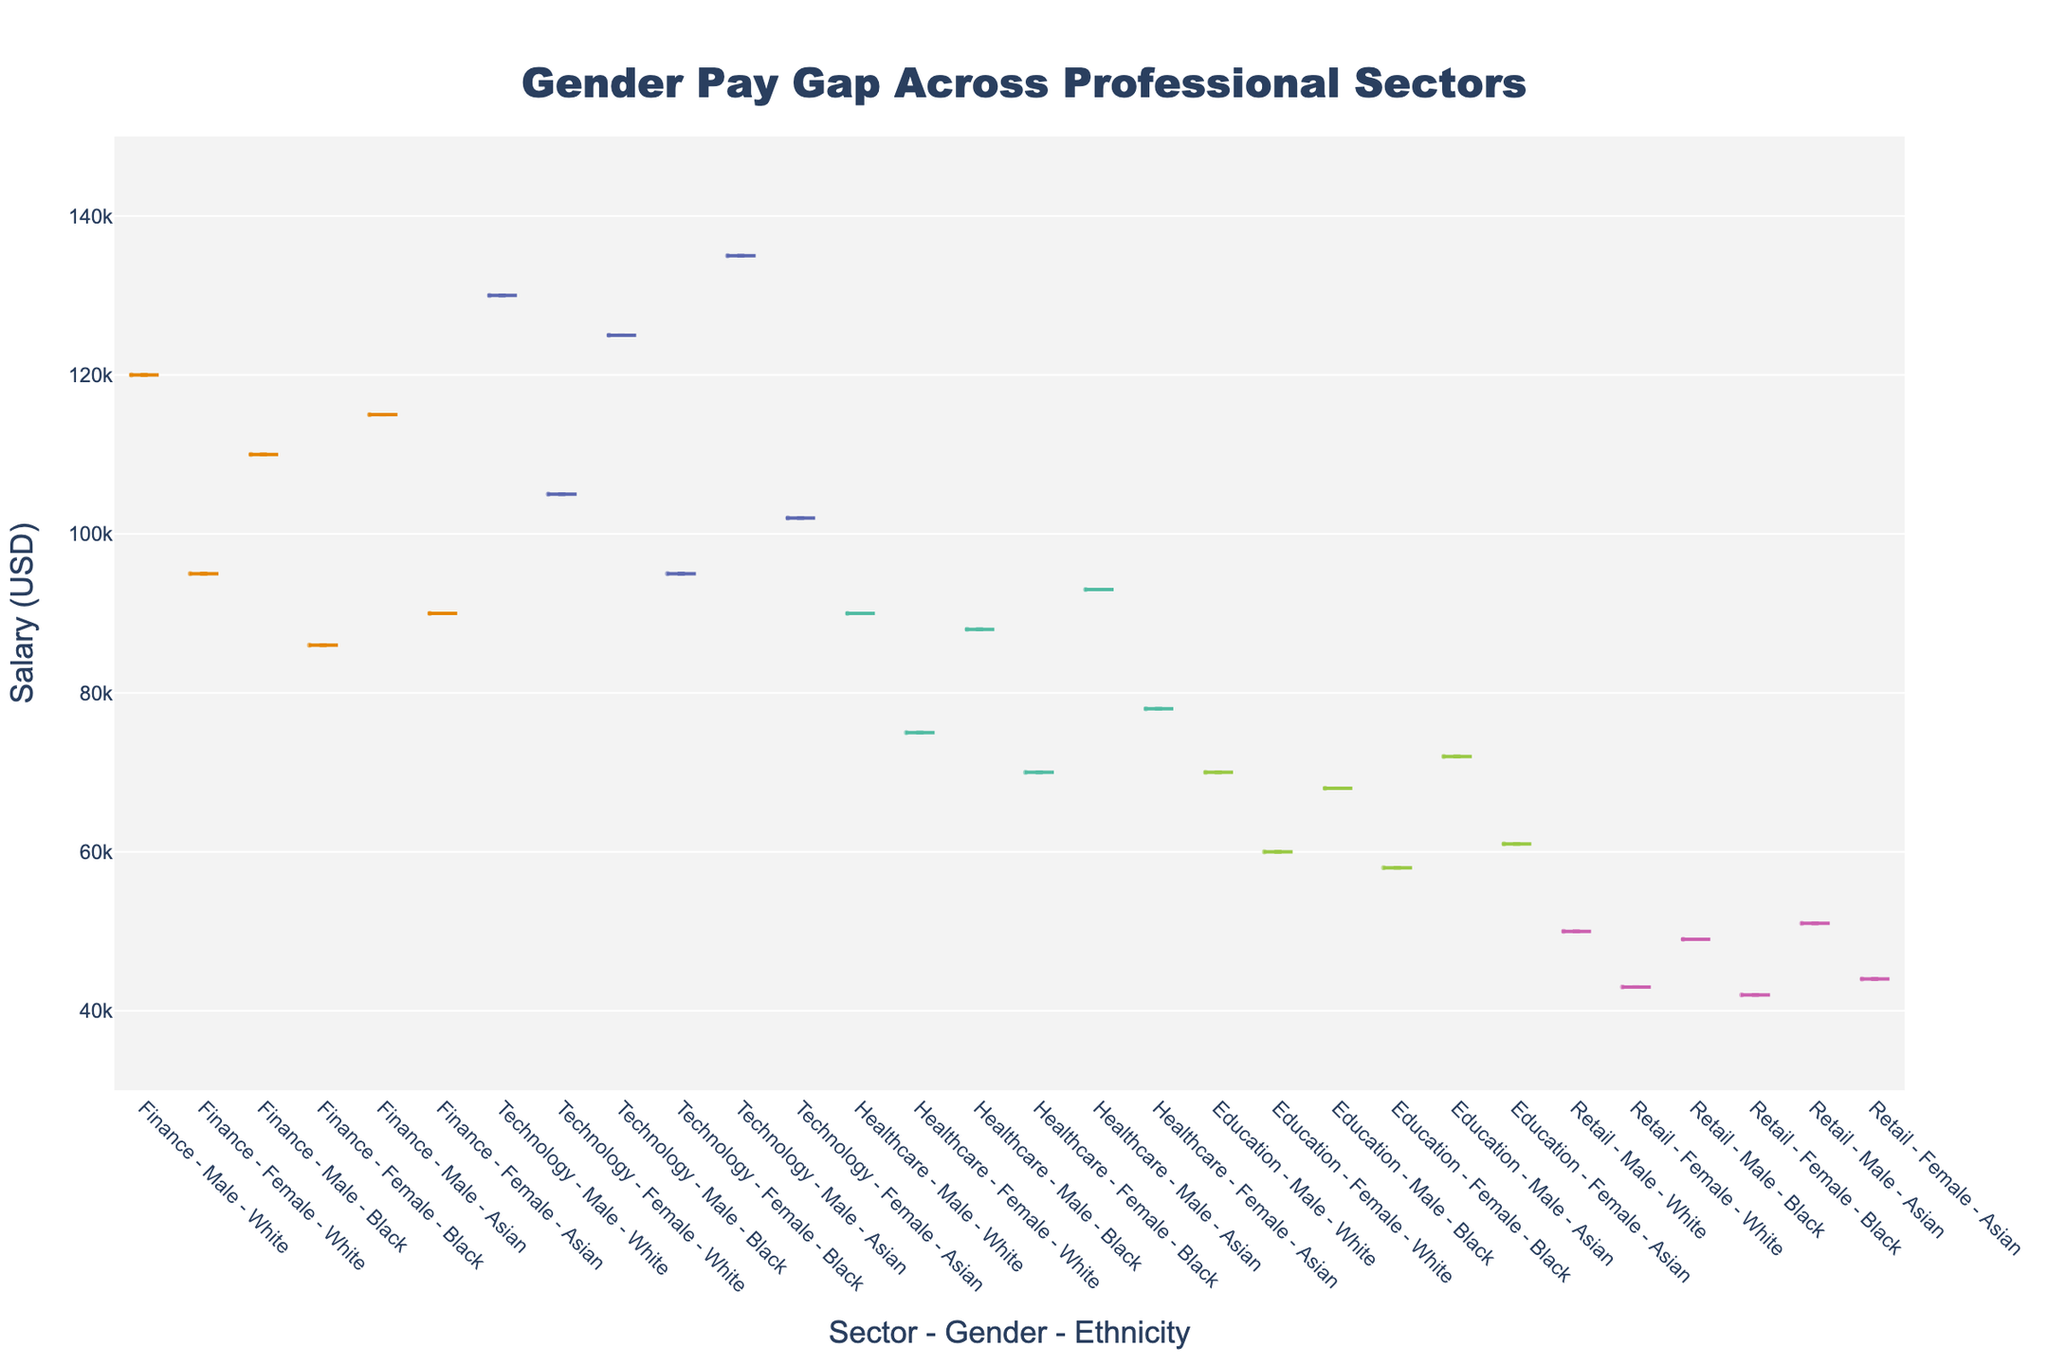What's the title of the figure? The title is usually at the top of the figure, and for this figure, it is explicitly mentioned in the `update_layout` section of the code. It reads: "Gender Pay Gap Across Professional Sectors"
Answer: Gender Pay Gap Across Professional Sectors What are the axes titles? Axes titles are specified in the `update_layout` section too. The x-axis title is "Sector - Gender - Ethnicity" and the y-axis title is "Salary (USD)".
Answer: x-axis: Sector - Gender - Ethnicity, y-axis: Salary (USD) Which professional sector shows the highest male salary? By looking at the distribution of salaries within the different sectors for males, the Technology sector shows the highest points on the y-axis for male salaries.
Answer: Technology Which professional sector shows the lowest female salary? Comparing the distributions for females across different sectors, the Retail sector displays the lowest points on the y-axis for female salaries.
Answer: Retail What is the median salary for females in the Finance sector? The box plot within the violin chart shows the median as a line inside the box. For females in the Finance sector, this line is at a salary of $90,000.
Answer: $90,000 In which sector is the gender pay gap most prominent in terms of median salary? Comparing the medians visible in the box plots for each sector, the Technology sector shows the largest gap between male ($130,000) and female ($105,000) median salaries.
Answer: Technology How does the salary distribution for Asian females in the Healthcare sector appear compared to Asian males in the same sector? The violin plot's shape indicates the distribution; Asian females in Healthcare have a lower and more compressed distribution compared to their male counterparts whose distribution is slightly more spread out and higher.
Answer: Lower and more compressed for females Which gender and ethnicity combination in the Education sector has the lowest salary? By examining all combinations in the Education sector, Black females show the lowest points on the y-axis for salary.
Answer: Black females What is the range of salaries for Black males in the Finance sector? The range of the salaries is seen from the spread of the data points in the violin plot; for Black males, the salary ranges from about $100,000 to $120,000.
Answer: $100,000 to $120,000 How do the salaries of White females compare across Finance and Technology sectors? Comparing the locations of White females in both Finance and Technology sectors, the salaries in Technology are typically higher than those in Finance.
Answer: Higher in Technology 